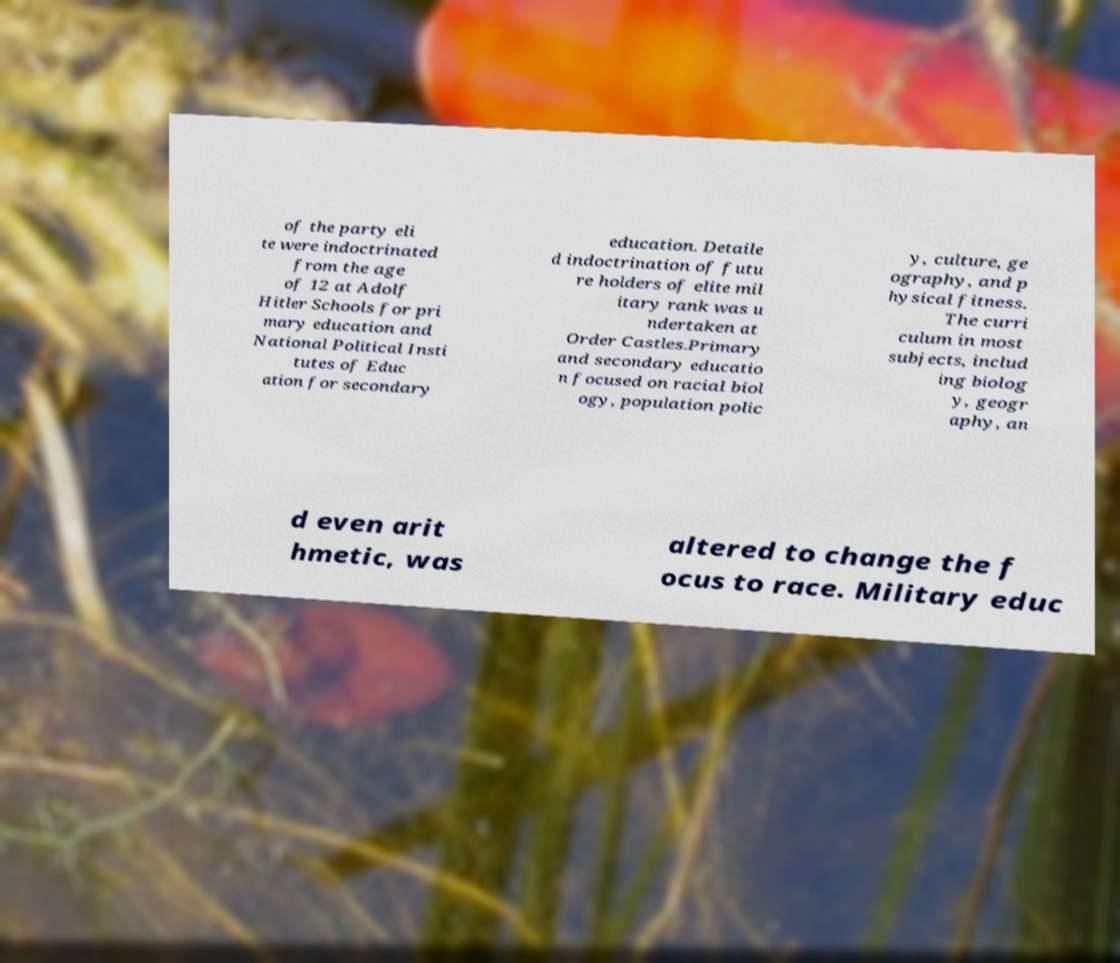For documentation purposes, I need the text within this image transcribed. Could you provide that? of the party eli te were indoctrinated from the age of 12 at Adolf Hitler Schools for pri mary education and National Political Insti tutes of Educ ation for secondary education. Detaile d indoctrination of futu re holders of elite mil itary rank was u ndertaken at Order Castles.Primary and secondary educatio n focused on racial biol ogy, population polic y, culture, ge ography, and p hysical fitness. The curri culum in most subjects, includ ing biolog y, geogr aphy, an d even arit hmetic, was altered to change the f ocus to race. Military educ 